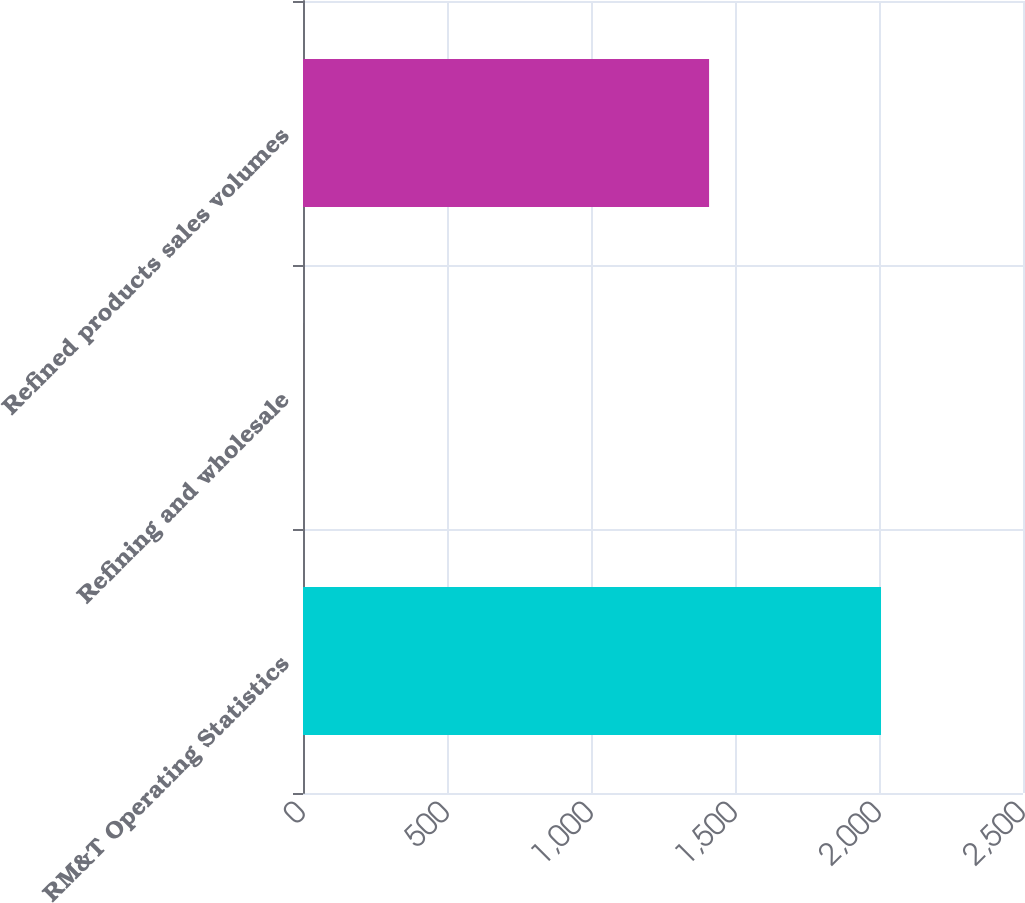Convert chart to OTSL. <chart><loc_0><loc_0><loc_500><loc_500><bar_chart><fcel>RM&T Operating Statistics<fcel>Refining and wholesale<fcel>Refined products sales volumes<nl><fcel>2007<fcel>0.18<fcel>1410<nl></chart> 